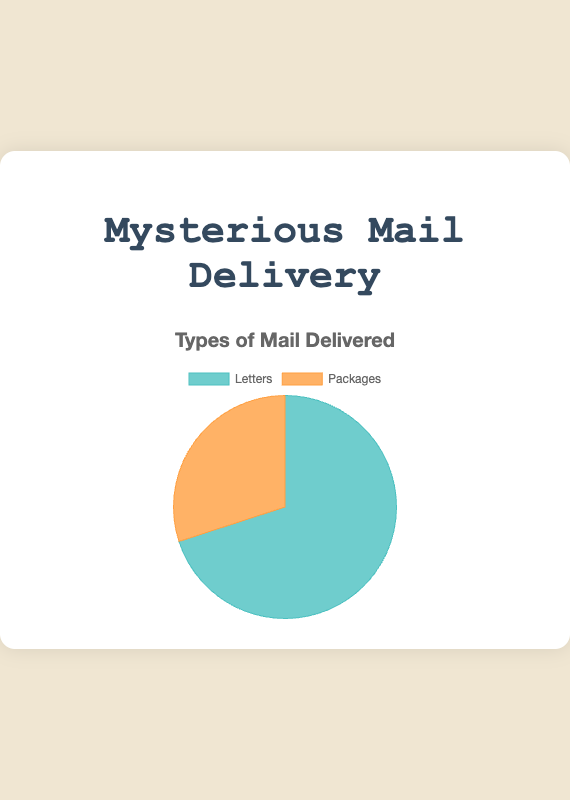What percentage of the total mail delivered are letters? To find the percentage of letters, divide the number of letters by the total mail delivered (letters + packages) and multiply by 100. 7000 letters out of 10000 total mail is (7000/10000) * 100 = 70%.
Answer: 70% How much more frequent are letters compared to packages? Subtract the number of packages from the number of letters. 7000 letters minus 3000 packages equals 4000 more letters delivered.
Answer: 4000 If the total mail delivered this month was 15000, with 7000 letters, how many packages were delivered? Subtract the number of letters from the total mail. 15000 total mail minus 7000 letters equals 8000 packages.
Answer: 8000 Which type of mail has a higher delivery count? Compare the delivery counts directly. Letters have 7000 and packages have 3000. Letters have a higher delivery count.
Answer: Letters What is the ratio of letters to packages delivered? Divide the number of letters by the number of packages. 7000 letters divided by 3000 packages is a ratio of 7000:3000, which simplifies to approximately 7:3.
Answer: 7:3 How many more letters are delivered than packages per 1000 deliveries? Determine the difference per 1000 deliveries by first finding the total number of mail per 1000 deliveries (relative terms). There are 7000/1000 = 7 letters for every 3000/1000 = 3 packages, so 7 - 3 equals 4 more letters per 1000 deliveries.
Answer: 4 If the deliveries doubled next month, how many more items of each type would be delivered? Multiply each type by 2. For letters: 7000 * 2 = 14000. For packages: 3000 * 2 = 6000. The increase is 14000 - 7000 = 7000 for letters and 6000 - 3000 = 3000 for packages.
Answer: Letters: 7000 more, Packages: 3000 more What color represents packages in the chart? Observing the colors associated with each category in the chart, packages are represented by the orange color.
Answer: Orange 